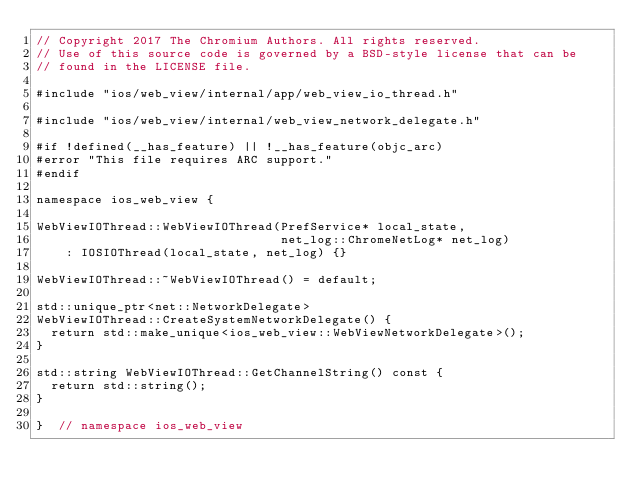Convert code to text. <code><loc_0><loc_0><loc_500><loc_500><_ObjectiveC_>// Copyright 2017 The Chromium Authors. All rights reserved.
// Use of this source code is governed by a BSD-style license that can be
// found in the LICENSE file.

#include "ios/web_view/internal/app/web_view_io_thread.h"

#include "ios/web_view/internal/web_view_network_delegate.h"

#if !defined(__has_feature) || !__has_feature(objc_arc)
#error "This file requires ARC support."
#endif

namespace ios_web_view {

WebViewIOThread::WebViewIOThread(PrefService* local_state,
                                 net_log::ChromeNetLog* net_log)
    : IOSIOThread(local_state, net_log) {}

WebViewIOThread::~WebViewIOThread() = default;

std::unique_ptr<net::NetworkDelegate>
WebViewIOThread::CreateSystemNetworkDelegate() {
  return std::make_unique<ios_web_view::WebViewNetworkDelegate>();
}

std::string WebViewIOThread::GetChannelString() const {
  return std::string();
}

}  // namespace ios_web_view
</code> 